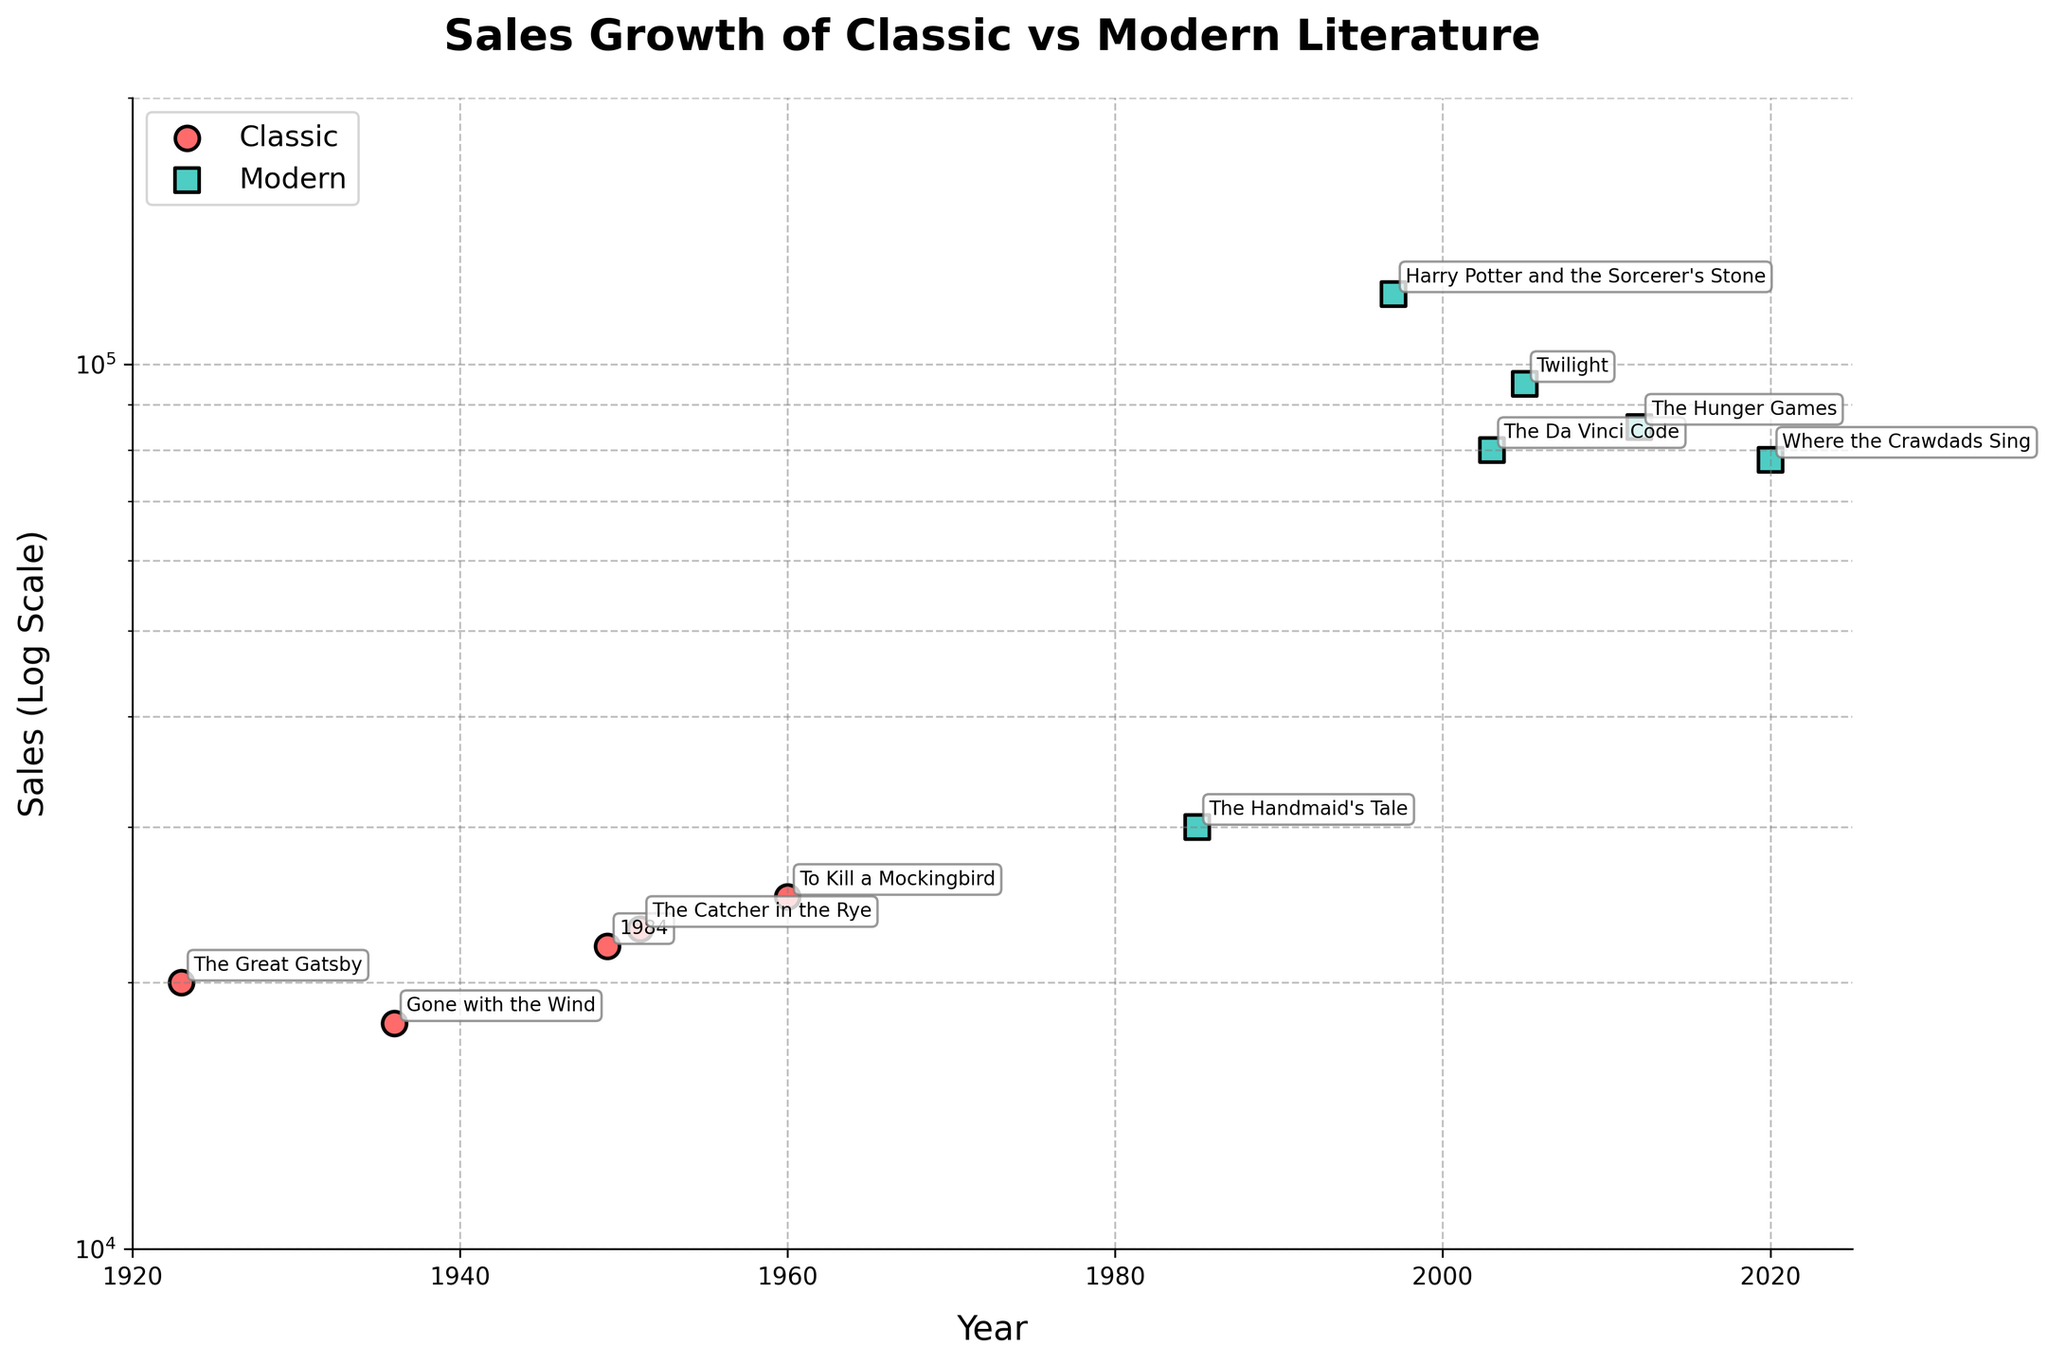What's the title of the plot? The title is displayed at the top of the plot in bold and larger font size. It reads: "Sales Growth of Classic vs Modern Literature".
Answer: Sales Growth of Classic vs Modern Literature What is the value range for the sales axis? The sales axis is labeled "Sales (Log Scale)" and the values range from approximately 10,000 to 200,000.
Answer: 10,000 to 200,000 How many classic novels are shown in the plot? Classic novels are represented by circular markers. Counting the number of circular markers in the plot gives the total number of classic novels.
Answer: 5 Which genre has the highest recorded sales, and for which book? The highest point on the scatter plot corresponds to the book with the highest recorded sales. By checking the highest point, "Harry Potter and the Sorcerer's Stone" which is a modern novel, has the highest sales.
Answer: Modern, Harry Potter and the Sorcerer's Stone What is the lowest sales value for modern literature in the plot? The sales values are on a log scale, so we look for the lowest point among the square markers, which represents modern literature. The lowest point is around 30,000 for "The Handmaid's Tale".
Answer: 30,000 How do the sales of "The Great Gatsby" compare to "The Catcher in the Rye"? Locate "The Great Gatsby" and "The Catcher in the Rye" on the plot. "The Great Gatsby" sales are at 20,000, while "The Catcher in the Rye" sales are at 23,000. "The Catcher in the Rye" has higher sales.
Answer: "The Catcher in the Rye" has higher sales Has sales for modern literature generally increased, decreased, or stayed the same over time? Examine the trend of sales values for modern literature by looking at the square markers from left to right. There is a general upward trend indicating an increase.
Answer: Increased What is the average sales value of the classic novels? Sum the sales of classic novels: 20000 + 18000 + 22000 + 23000 + 25000 = 108000. Divide by the number of classic novels, which is 5. The average is 108000 / 5 = 21600.
Answer: 21600 By how much did sales increase from "The Handmaid’s Tale" to "The Da Vinci Code"? Identify the sales values for "The Handmaid’s Tale" (30,000) and "The Da Vinci Code" (80,000). Subtract the former from the latter: 80,000 - 30,000 = 50,000.
Answer: 50,000 What can you infer from the consistent increase in sales values when moving from early to recent dates in modern literature? The continuous increase in sales values for modern literature over the years suggests a growing market or increased popularity for modern books as time progresses.
Answer: Growing market/increased popularity 